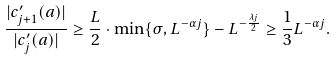<formula> <loc_0><loc_0><loc_500><loc_500>\frac { | c _ { j + 1 } ^ { \prime } ( a ) | } { | c _ { j } ^ { \prime } ( a ) | } \geq \frac { L } { 2 } \cdot \min \{ \sigma , L ^ { - \alpha j } \} - L ^ { - \frac { \lambda j } { 2 } } \geq \frac { 1 } { 3 } L ^ { - \alpha j } .</formula> 